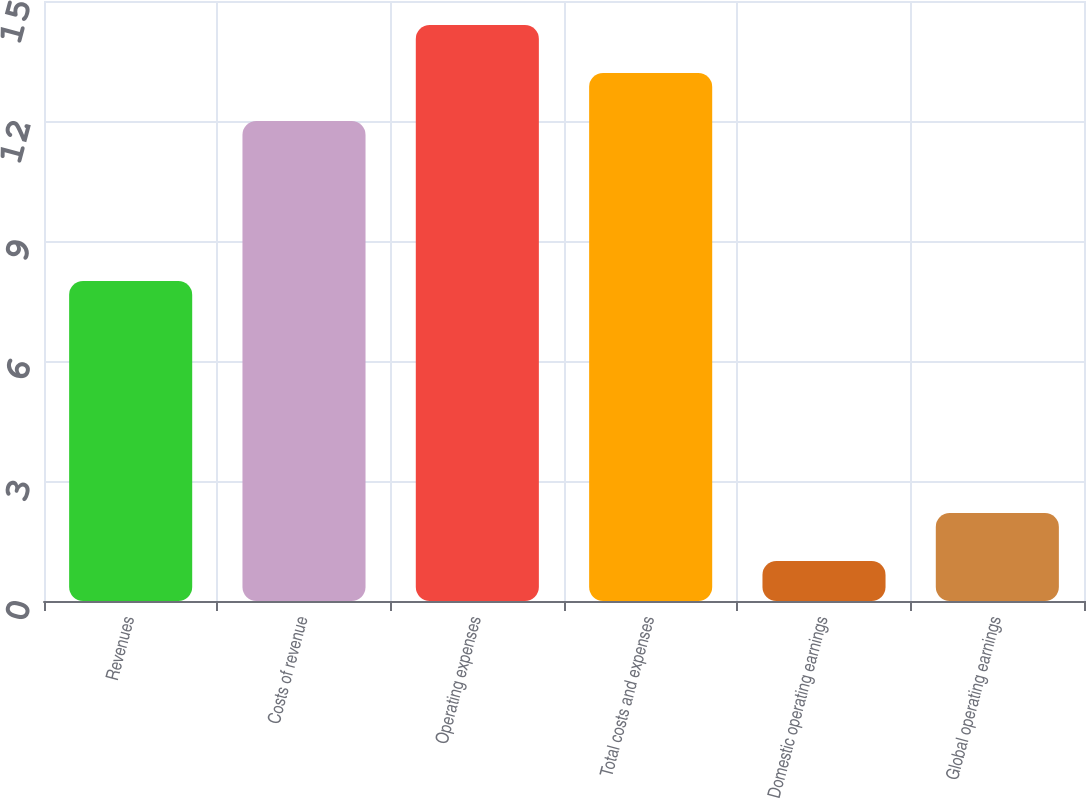Convert chart to OTSL. <chart><loc_0><loc_0><loc_500><loc_500><bar_chart><fcel>Revenues<fcel>Costs of revenue<fcel>Operating expenses<fcel>Total costs and expenses<fcel>Domestic operating earnings<fcel>Global operating earnings<nl><fcel>8<fcel>12<fcel>14.4<fcel>13.2<fcel>1<fcel>2.2<nl></chart> 